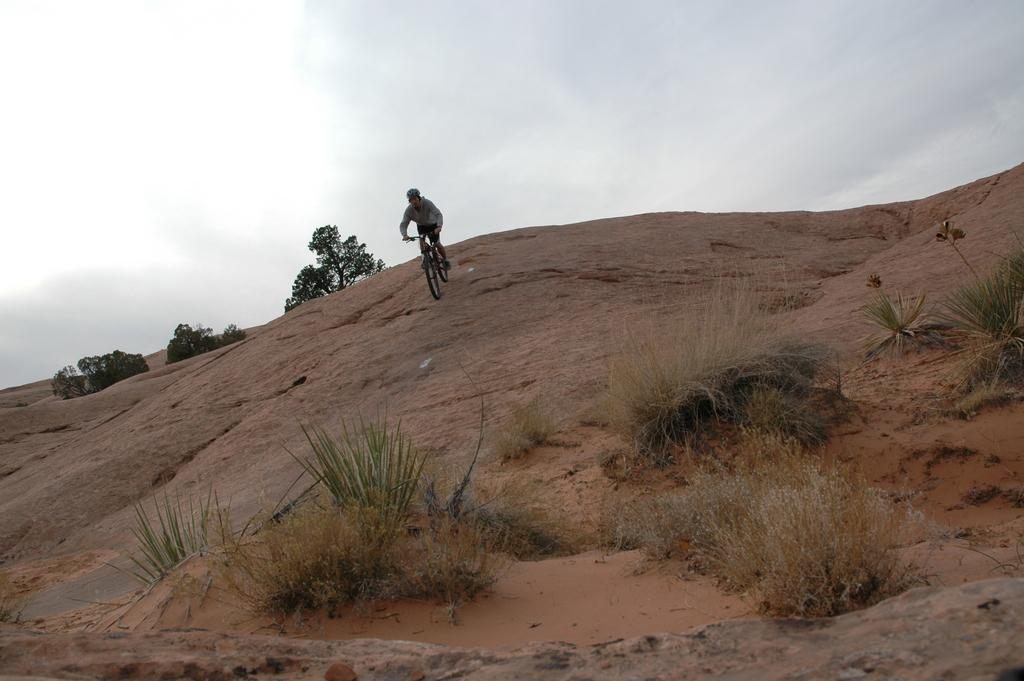What type of landscape is depicted in the image? The image features hills. What can be seen on the hills? There are stones with plants and trees on the hills. What activity is the person in the image engaged in? The person is riding a bicycle on a hill stone. What is visible in the background of the image? The sky is visible in the image, and there are clouds in the sky. How many quills are attached to the tramp in the image? There is no tramp or quills present in the image. What is the fifth element in the image? The provided facts do not mention a fifth element in the image. 